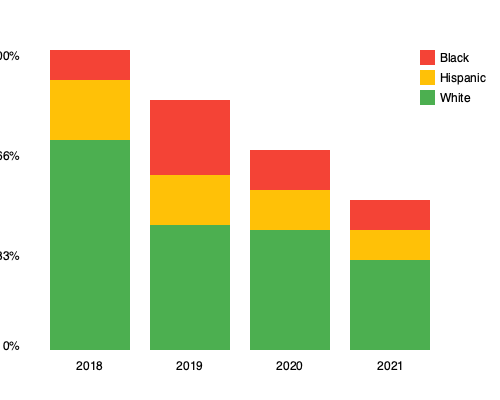Based on the stacked bar chart showing racial profiling statistics from 2018 to 2021, what trend can be observed in the proportion of Black individuals subject to police stops, and how might this information guide policy reforms as the city mayor? To answer this question, let's analyze the data step-by-step:

1. Identify the representation of Black individuals:
   - Black individuals are represented by the red (top) portion of each bar.

2. Observe the trend for Black individuals from 2018 to 2021:
   - 2018: Approximately 10% of stops
   - 2019: Approximately 30% of stops
   - 2020: Approximately 20% of stops
   - 2021: Approximately 20% of stops

3. Analyze the trend:
   - There was a significant increase from 2018 to 2019.
   - From 2019 to 2021, there has been a slight decrease and then stabilization.
   - Overall, the proportion of Black individuals stopped has increased since 2018.

4. Consider policy implications:
   - The increase in stops of Black individuals may indicate racial bias in policing.
   - As mayor, this data suggests a need for policy reforms to address potential racial profiling.
   - Possible reforms could include:
     a. Implementing bias training for police officers.
     b. Reviewing and revising stop and search policies.
     c. Increasing community engagement and dialogue.
     d. Establishing an independent review board for police practices.

5. Conclusion:
   The data shows an overall increase in the proportion of Black individuals subject to police stops from 2018 to 2021, with some stabilization in recent years. This trend indicates a need for policy reforms to address potential racial bias in law enforcement practices.
Answer: Increased proportion of Black individuals stopped; requires policy reforms to address potential racial bias. 